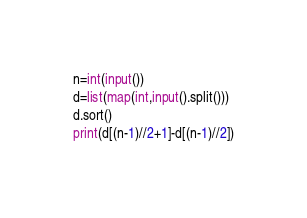Convert code to text. <code><loc_0><loc_0><loc_500><loc_500><_Python_>n=int(input())
d=list(map(int,input().split()))
d.sort()
print(d[(n-1)//2+1]-d[(n-1)//2])</code> 